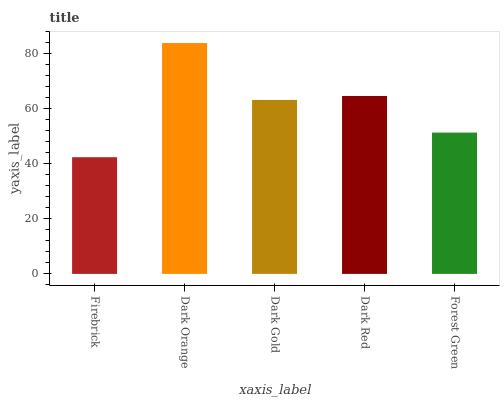Is Dark Gold the minimum?
Answer yes or no. No. Is Dark Gold the maximum?
Answer yes or no. No. Is Dark Orange greater than Dark Gold?
Answer yes or no. Yes. Is Dark Gold less than Dark Orange?
Answer yes or no. Yes. Is Dark Gold greater than Dark Orange?
Answer yes or no. No. Is Dark Orange less than Dark Gold?
Answer yes or no. No. Is Dark Gold the high median?
Answer yes or no. Yes. Is Dark Gold the low median?
Answer yes or no. Yes. Is Forest Green the high median?
Answer yes or no. No. Is Forest Green the low median?
Answer yes or no. No. 